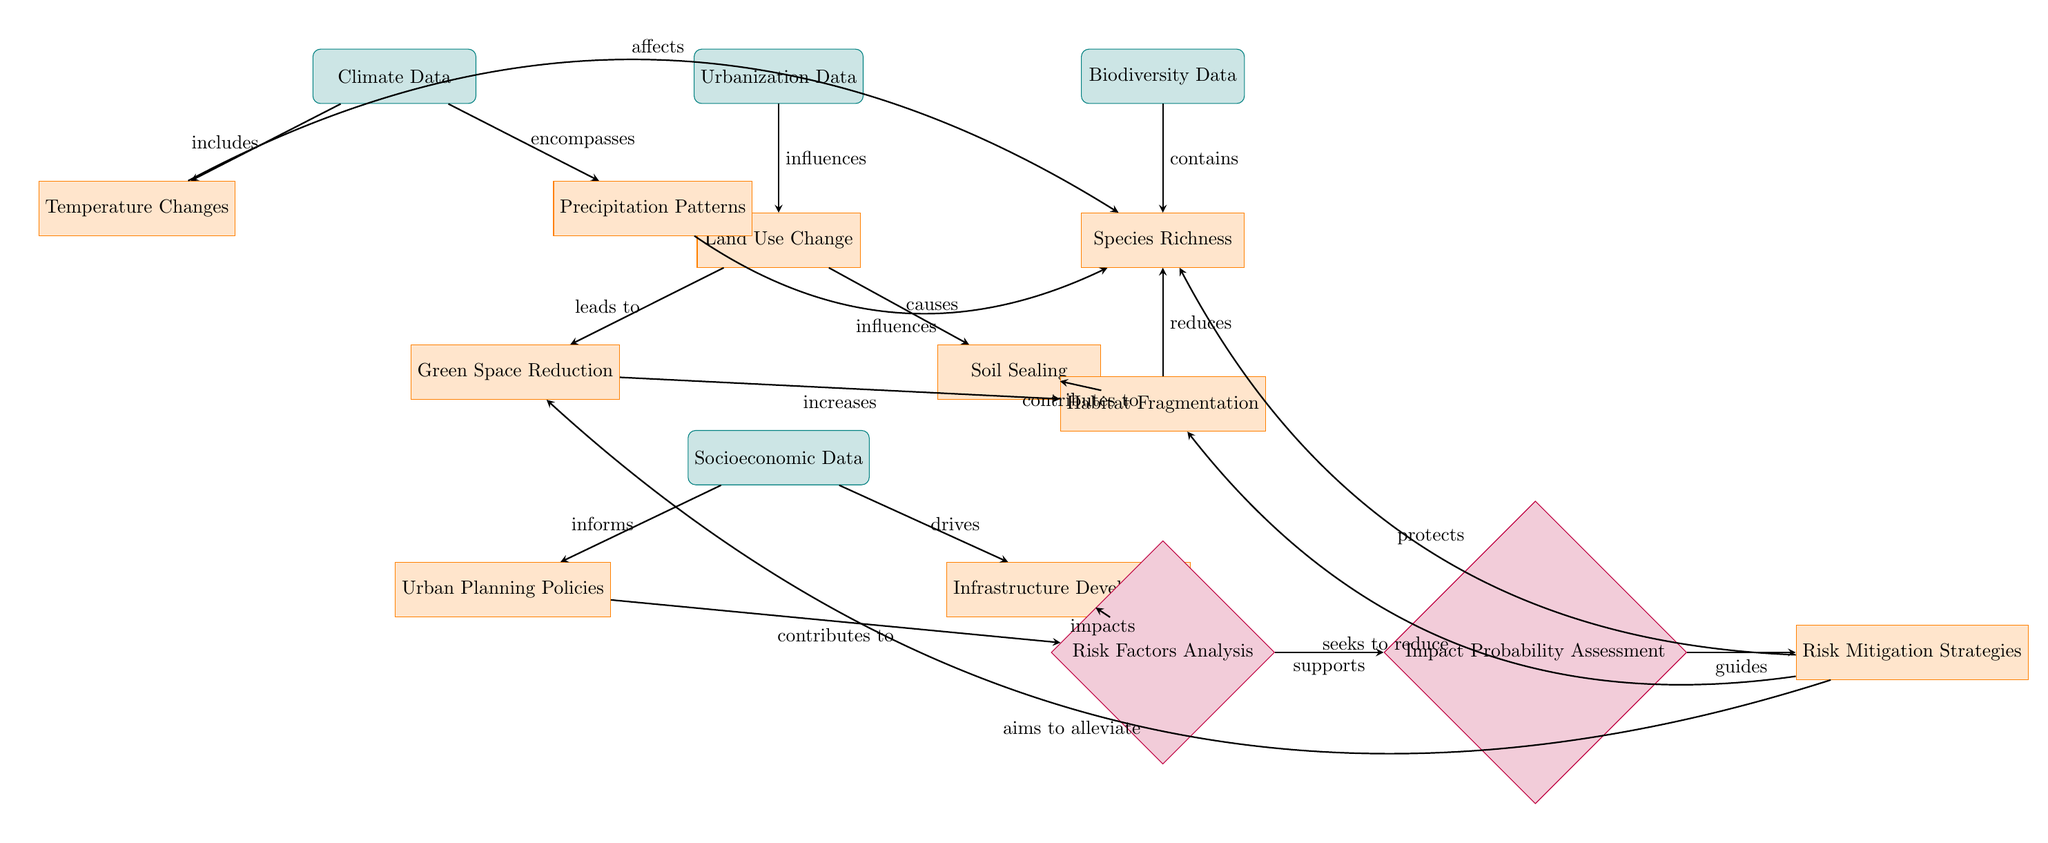What type of data does the risk assessment model use? The diagram shows three types of data: Urbanization Data, Biodiversity Data, and Climate Data. This is indicated by the three data nodes at the top and sides.
Answer: Urbanization Data, Biodiversity Data, Climate Data How many processes are represented in the diagram? The diagram includes five processes: Land Use Change, Green Space Reduction, Soil Sealing, Species Richness, and Habitat Fragmentation. These are identified as the orange and yellow nodes.
Answer: Five Which element leads to habitat fragmentation? The diagram shows two processes that contribute to habitat fragmentation: Green Space Reduction and Soil Sealing. The arrows indicate that both processes project their influence onto habitat fragmentation.
Answer: Green Space Reduction and Soil Sealing What factors inform risk factors analysis? The risk factors analysis is informed by two processes: Urban Planning Policies and Infrastructure Development. This is shown by the arrows pointing from these processes to the risk factors analysis node.
Answer: Urban Planning Policies and Infrastructure Development Which step follows risk factors analysis in the risk assessment model? After risk factors analysis, the next step indicated in the diagram is Impact Probability Assessment. An arrow directly connects risk factors analysis to this step.
Answer: Impact Probability Assessment How does climate data affect species richness? The diagram demonstrates that both Temperature Changes and Precipitation Patterns from Climate Data affect Species Richness, shown by the arrows that lead from these processes to the species node.
Answer: Temperature Changes and Precipitation Patterns What is the final goal of the risk mitigation strategies? The risk mitigation strategies aim to alleviate Green Space Reduction, reduce Habitat Fragmentation, and protect Species Richness, as indicated by the arrows leading from the mitigation node to these three processes.
Answer: Alleviate Green Space Reduction, Reduce Habitat Fragmentation, Protect Species Richness Which data influence urbanization? The diagram illustrates that Urbanization Data influences Land Use Change, as denoted by the arrow connecting these two nodes.
Answer: Urbanization Data How many risk mitigation strategies are mentioned? The diagram shows that there are three distinct efforts for risk mitigation regarding green space, habitat, and species, represented by arrows originating from the mitigation node.
Answer: Three 